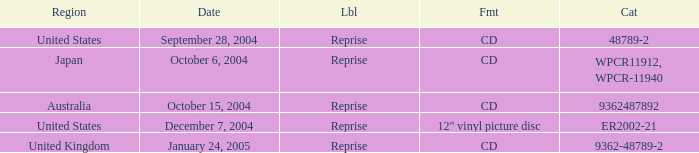Name the date that is a cd September 28, 2004, October 6, 2004, October 15, 2004, January 24, 2005. 